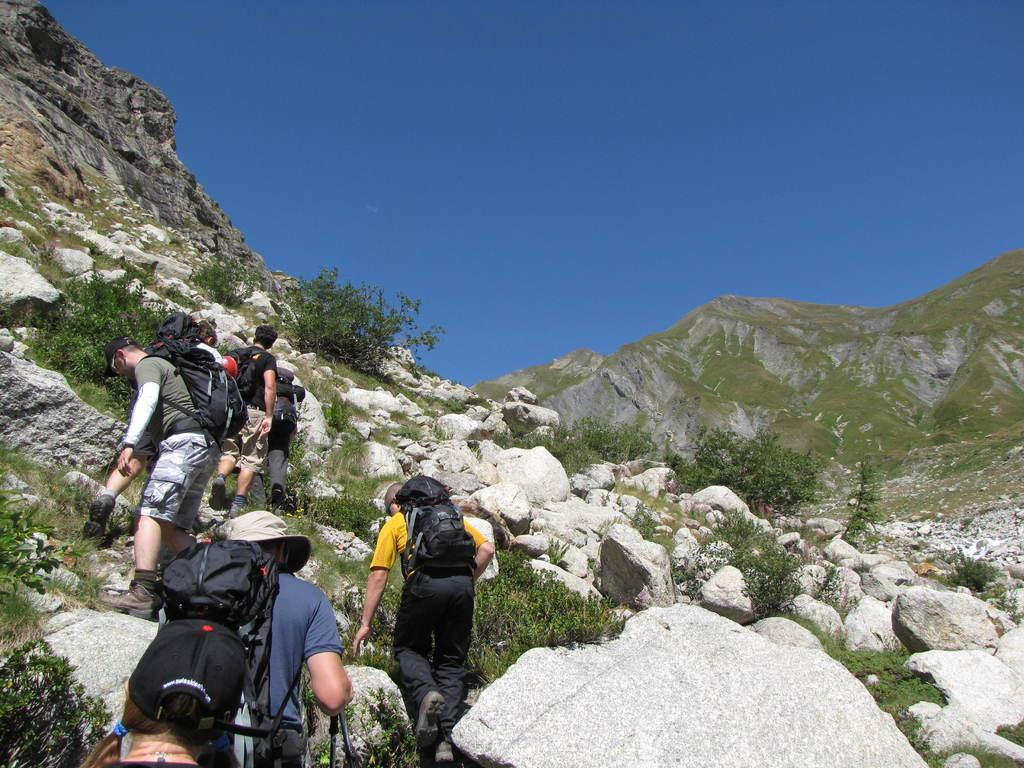Who or what can be seen in the image? There are people in the image. What are the people wearing on their backs? The people are wearing backpacks. What activity are the people engaged in? The people are climbing a hill. What type of natural elements can be seen in the image? Plants and rocks are visible in the image. What is the color of the sky in the image? The sky is blue in the image. What type of ticket is required to enter the frame in the image? There is no frame or ticket present in the image; it is a photograph of people climbing a hill. 